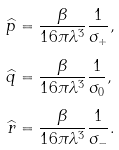<formula> <loc_0><loc_0><loc_500><loc_500>\widehat { p } & = \frac { \beta } { 1 6 \pi \lambda ^ { 3 } } \frac { 1 } { \sigma _ { + } } , \\ \widehat { q } & = \frac { \beta } { 1 6 \pi \lambda ^ { 3 } } \frac { 1 } { \sigma _ { 0 } } , \\ \widehat { r } & = \frac { \beta } { 1 6 \pi \lambda ^ { 3 } } \frac { 1 } { \sigma _ { - } } .</formula> 